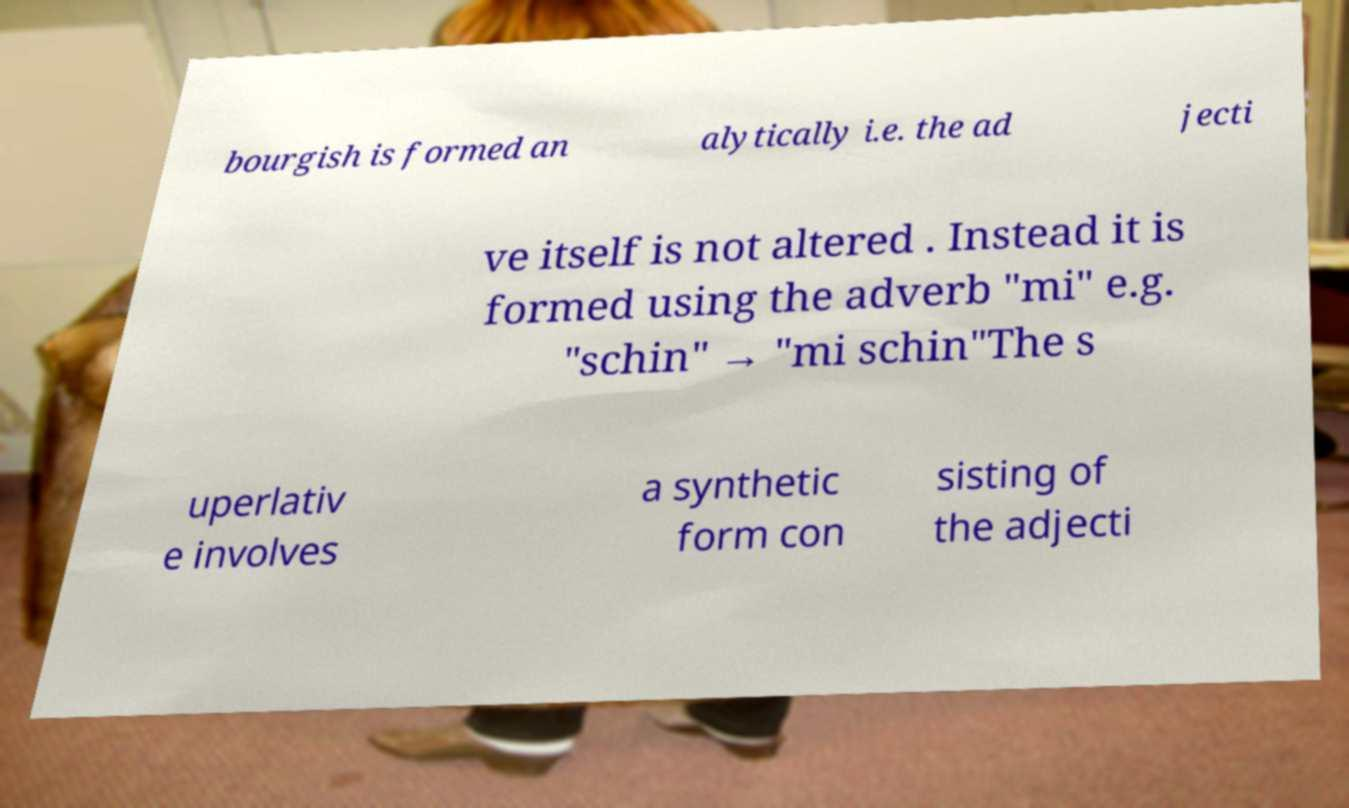There's text embedded in this image that I need extracted. Can you transcribe it verbatim? bourgish is formed an alytically i.e. the ad jecti ve itself is not altered . Instead it is formed using the adverb "mi" e.g. "schin" → "mi schin"The s uperlativ e involves a synthetic form con sisting of the adjecti 